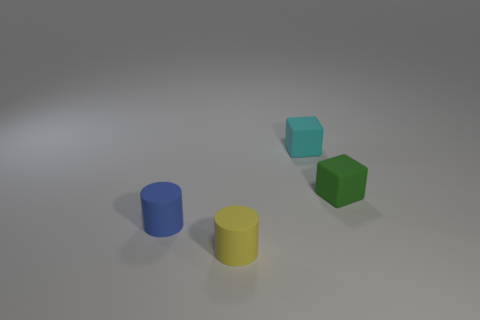Add 4 blue rubber things. How many objects exist? 8 Subtract all small green cubes. Subtract all gray cylinders. How many objects are left? 3 Add 2 small cyan blocks. How many small cyan blocks are left? 3 Add 3 yellow things. How many yellow things exist? 4 Subtract 0 gray cubes. How many objects are left? 4 